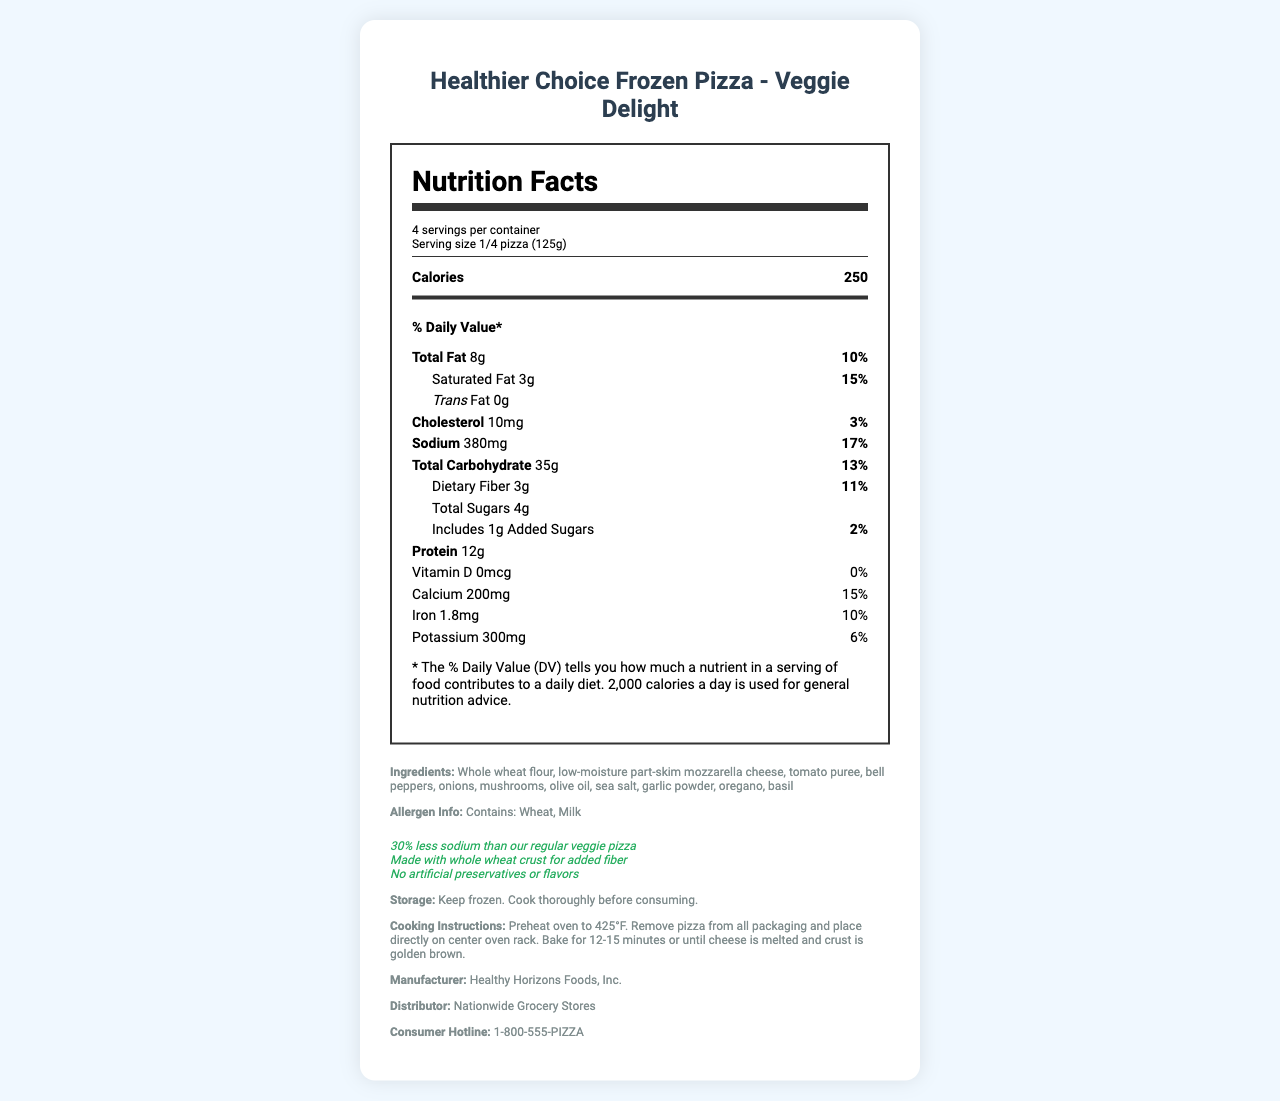what is the serving size of the pizza? The serving size is listed under the servings per container section in the Nutrition Facts label.
Answer: 1/4 pizza (125g) how many calories are there per serving? The calories per serving is mentioned prominently at the top of the Nutrition Facts label.
Answer: 250 what percentage of the daily value is total fat per serving? The daily value percentage for total fat is shown next to the total fat amount in the Nutrition Facts label.
Answer: 10% which ingredient is listed first in the ingredient list? Ingredients are listed in order of quantity, and whole wheat flour is the first ingredient mentioned.
Answer: Whole wheat flour what is the amount of sodium per serving? The amount of sodium per serving is displayed in the Nutrition Facts label, and it lists 380mg.
Answer: 380mg how many servings are in the container? A. 2 B. 3 C. 4 D. 5 It is stated that there are 4 servings per container in the serving information section.
Answer: C. 4 what is the daily value percentage for dietary fiber? A. 0% B. 6% C. 11% D. 15% The daily value percentage for dietary fiber is listed as 11% in the Nutrition Facts label.
Answer: C. 11% is there any trans fat in the pizza? The amount of trans fat is listed as 0g in the Nutrition Facts label, indicating that there is no trans fat in the pizza.
Answer: No does the product contain any artificial preservatives or flavors? The health claims section states that the product contains no artificial preservatives or flavors.
Answer: No summarize the main features of the Healthier Choice Frozen Pizza – Veggie Delight. The main features are derived from the Nutrition Facts, ingredient list, and health claims sections that highlight its nutritional benefits and distinguishing characteristics.
Answer: The Healthier Choice Frozen Pizza – Veggie Delight is a low sodium and reduced fat frozen pizza with a whole wheat crust for added fiber. Each serving contains 250 calories, 8g of total fat, 380mg of sodium, and 12g of protein. The product is free from artificial preservatives and flavors and is designed to be a healthier alternative to regular veggie pizzas. what is the total cooking time required for the pizza? The document specifies the baking time (12-15 minutes) but does not include the preheating time for the oven.
Answer: Not enough information is there any cholesterol in the pizza? The Nutrition Facts label indicates that there is 10mg of cholesterol per serving, which is 3% of the daily value.
Answer: Yes 